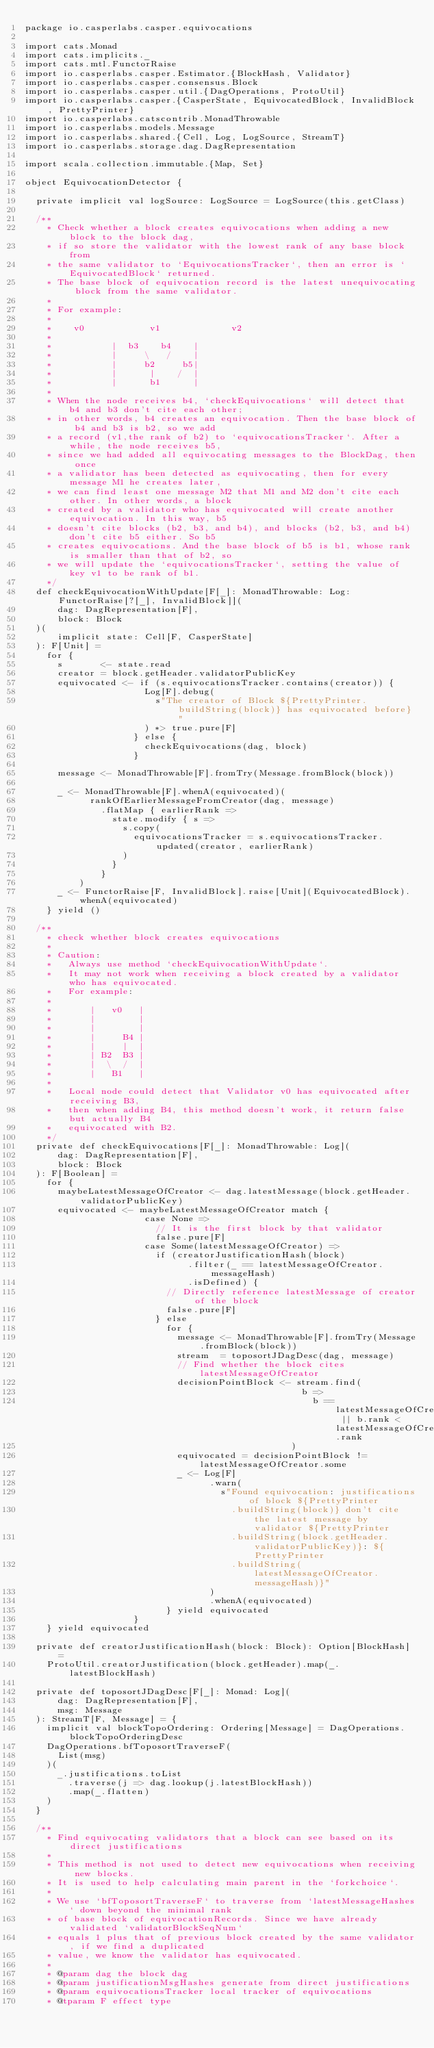<code> <loc_0><loc_0><loc_500><loc_500><_Scala_>package io.casperlabs.casper.equivocations

import cats.Monad
import cats.implicits._
import cats.mtl.FunctorRaise
import io.casperlabs.casper.Estimator.{BlockHash, Validator}
import io.casperlabs.casper.consensus.Block
import io.casperlabs.casper.util.{DagOperations, ProtoUtil}
import io.casperlabs.casper.{CasperState, EquivocatedBlock, InvalidBlock, PrettyPrinter}
import io.casperlabs.catscontrib.MonadThrowable
import io.casperlabs.models.Message
import io.casperlabs.shared.{Cell, Log, LogSource, StreamT}
import io.casperlabs.storage.dag.DagRepresentation

import scala.collection.immutable.{Map, Set}

object EquivocationDetector {

  private implicit val logSource: LogSource = LogSource(this.getClass)

  /**
    * Check whether a block creates equivocations when adding a new block to the block dag,
    * if so store the validator with the lowest rank of any base block from
    * the same validator to `EquivocationsTracker`, then an error is `EquivocatedBlock` returned.
    * The base block of equivocation record is the latest unequivocating block from the same validator.
    *
    * For example:
    *
    *    v0            v1             v2
    *
    *           |  b3    b4    |
    *           |     \   /    |
    *           |     b2     b5|
    *           |      |    /  |
    *           |      b1      |
    *
    * When the node receives b4, `checkEquivocations` will detect that b4 and b3 don't cite each other;
    * in other words, b4 creates an equivocation. Then the base block of b4 and b3 is b2, so we add
    * a record (v1,the rank of b2) to `equivocationsTracker`. After a while, the node receives b5,
    * since we had added all equivocating messages to the BlockDag, then once
    * a validator has been detected as equivocating, then for every message M1 he creates later,
    * we can find least one message M2 that M1 and M2 don't cite each other. In other words, a block
    * created by a validator who has equivocated will create another equivocation. In this way, b5
    * doesn't cite blocks (b2, b3, and b4), and blocks (b2, b3, and b4) don't cite b5 either. So b5
    * creates equivocations. And the base block of b5 is b1, whose rank is smaller than that of b2, so
    * we will update the `equivocationsTracker`, setting the value of key v1 to be rank of b1.
    */
  def checkEquivocationWithUpdate[F[_]: MonadThrowable: Log: FunctorRaise[?[_], InvalidBlock]](
      dag: DagRepresentation[F],
      block: Block
  )(
      implicit state: Cell[F, CasperState]
  ): F[Unit] =
    for {
      s       <- state.read
      creator = block.getHeader.validatorPublicKey
      equivocated <- if (s.equivocationsTracker.contains(creator)) {
                      Log[F].debug(
                        s"The creator of Block ${PrettyPrinter.buildString(block)} has equivocated before}"
                      ) *> true.pure[F]
                    } else {
                      checkEquivocations(dag, block)
                    }

      message <- MonadThrowable[F].fromTry(Message.fromBlock(block))

      _ <- MonadThrowable[F].whenA(equivocated)(
            rankOfEarlierMessageFromCreator(dag, message)
              .flatMap { earlierRank =>
                state.modify { s =>
                  s.copy(
                    equivocationsTracker = s.equivocationsTracker.updated(creator, earlierRank)
                  )
                }
              }
          )
      _ <- FunctorRaise[F, InvalidBlock].raise[Unit](EquivocatedBlock).whenA(equivocated)
    } yield ()

  /**
    * check whether block creates equivocations
    *
    * Caution:
    *   Always use method `checkEquivocationWithUpdate`.
    *   It may not work when receiving a block created by a validator who has equivocated.
    *   For example:
    *
    *       |   v0   |
    *       |        |
    *       |        |
    *       |     B4 |
    *       |     |  |
    *       | B2  B3 |
    *       |  \  /  |
    *       |   B1   |
    *
    *   Local node could detect that Validator v0 has equivocated after receiving B3,
    *   then when adding B4, this method doesn't work, it return false but actually B4
    *   equivocated with B2.
    */
  private def checkEquivocations[F[_]: MonadThrowable: Log](
      dag: DagRepresentation[F],
      block: Block
  ): F[Boolean] =
    for {
      maybeLatestMessageOfCreator <- dag.latestMessage(block.getHeader.validatorPublicKey)
      equivocated <- maybeLatestMessageOfCreator match {
                      case None =>
                        // It is the first block by that validator
                        false.pure[F]
                      case Some(latestMessageOfCreator) =>
                        if (creatorJustificationHash(block)
                              .filter(_ == latestMessageOfCreator.messageHash)
                              .isDefined) {
                          // Directly reference latestMessage of creator of the block
                          false.pure[F]
                        } else
                          for {
                            message <- MonadThrowable[F].fromTry(Message.fromBlock(block))
                            stream  = toposortJDagDesc(dag, message)
                            // Find whether the block cites latestMessageOfCreator
                            decisionPointBlock <- stream.find(
                                                   b =>
                                                     b == latestMessageOfCreator || b.rank < latestMessageOfCreator.rank
                                                 )
                            equivocated = decisionPointBlock != latestMessageOfCreator.some
                            _ <- Log[F]
                                  .warn(
                                    s"Found equivocation: justifications of block ${PrettyPrinter
                                      .buildString(block)} don't cite the latest message by validator ${PrettyPrinter
                                      .buildString(block.getHeader.validatorPublicKey)}: ${PrettyPrinter
                                      .buildString(latestMessageOfCreator.messageHash)}"
                                  )
                                  .whenA(equivocated)
                          } yield equivocated
                    }
    } yield equivocated

  private def creatorJustificationHash(block: Block): Option[BlockHash] =
    ProtoUtil.creatorJustification(block.getHeader).map(_.latestBlockHash)

  private def toposortJDagDesc[F[_]: Monad: Log](
      dag: DagRepresentation[F],
      msg: Message
  ): StreamT[F, Message] = {
    implicit val blockTopoOrdering: Ordering[Message] = DagOperations.blockTopoOrderingDesc
    DagOperations.bfToposortTraverseF(
      List(msg)
    )(
      _.justifications.toList
        .traverse(j => dag.lookup(j.latestBlockHash))
        .map(_.flatten)
    )
  }

  /**
    * Find equivocating validators that a block can see based on its direct justifications
    *
    * This method is not used to detect new equivocations when receiving new blocks.
    * It is used to help calculating main parent in the `forkchoice`.
    *
    * We use `bfToposortTraverseF` to traverse from `latestMessageHashes` down beyond the minimal rank
    * of base block of equivocationRecords. Since we have already validated `validatorBlockSeqNum`
    * equals 1 plus that of previous block created by the same validator, if we find a duplicated
    * value, we know the validator has equivocated.
    *
    * @param dag the block dag
    * @param justificationMsgHashes generate from direct justifications
    * @param equivocationsTracker local tracker of equivocations
    * @tparam F effect type</code> 